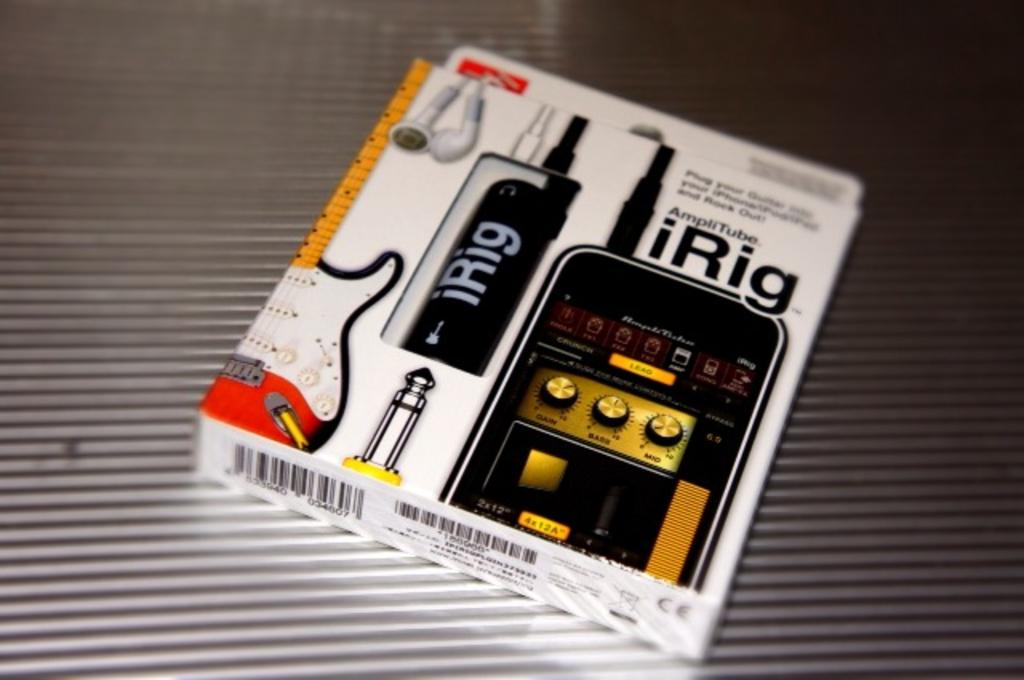<image>
Present a compact description of the photo's key features. A guitar accessory, called the AmpliTube iRig, is in its packaging. 